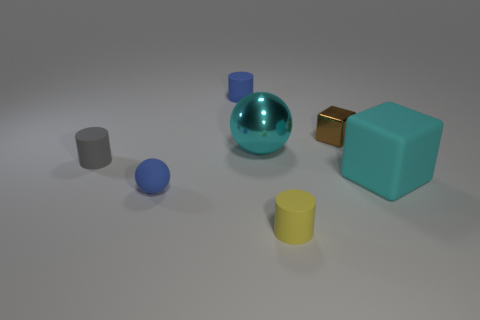How many objects are either tiny yellow rubber objects that are in front of the tiny brown metal cube or things that are behind the blue sphere?
Give a very brief answer. 6. Are there any other things that have the same color as the metal sphere?
Give a very brief answer. Yes. What color is the object to the left of the small blue matte object that is left of the blue rubber object right of the blue rubber ball?
Your answer should be very brief. Gray. There is a sphere right of the blue object that is in front of the big cyan metallic ball; what size is it?
Your answer should be compact. Large. What is the thing that is in front of the big block and on the right side of the tiny blue sphere made of?
Your response must be concise. Rubber. Does the brown thing have the same size as the cyan thing behind the cyan cube?
Your answer should be compact. No. Is there a small gray cylinder?
Your response must be concise. Yes. There is a brown object that is the same shape as the cyan rubber object; what is it made of?
Keep it short and to the point. Metal. How big is the yellow rubber cylinder that is right of the tiny blue object that is in front of the block that is in front of the shiny ball?
Ensure brevity in your answer.  Small. Are there any tiny objects behind the big cyan matte thing?
Offer a very short reply. Yes. 